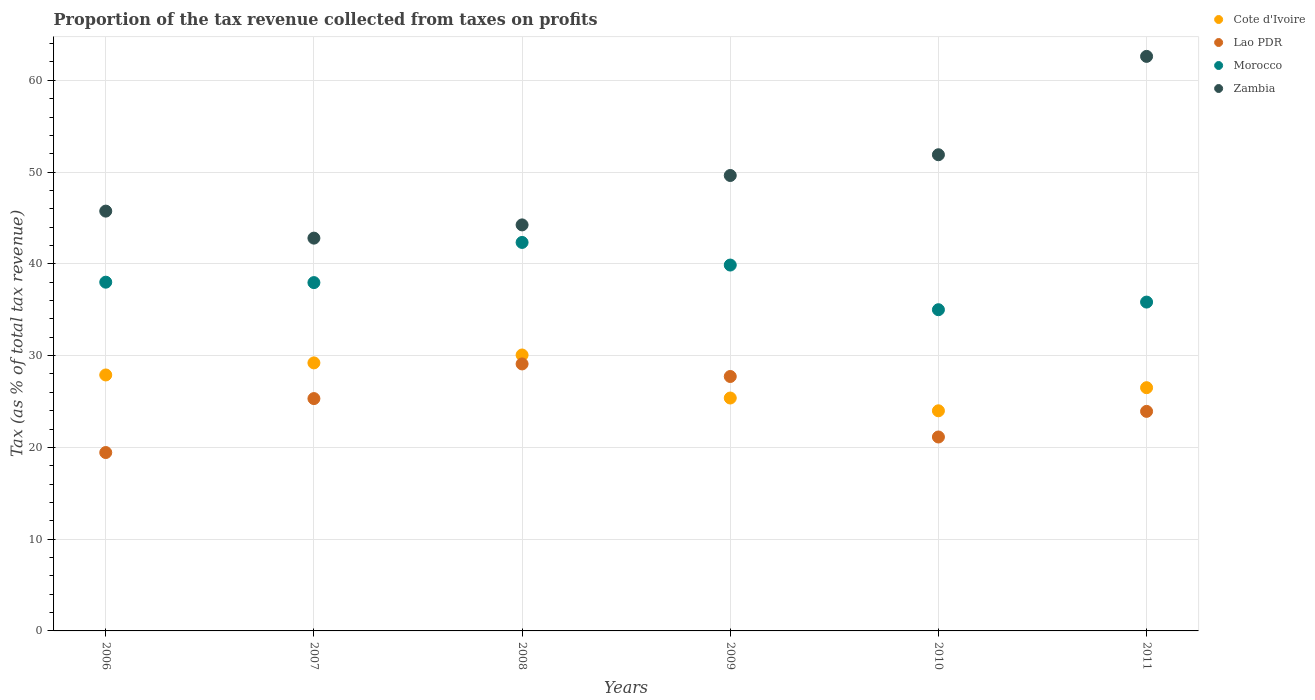Is the number of dotlines equal to the number of legend labels?
Your response must be concise. Yes. What is the proportion of the tax revenue collected in Lao PDR in 2006?
Offer a very short reply. 19.44. Across all years, what is the maximum proportion of the tax revenue collected in Cote d'Ivoire?
Give a very brief answer. 30.07. Across all years, what is the minimum proportion of the tax revenue collected in Lao PDR?
Ensure brevity in your answer.  19.44. What is the total proportion of the tax revenue collected in Zambia in the graph?
Your answer should be compact. 296.91. What is the difference between the proportion of the tax revenue collected in Lao PDR in 2008 and that in 2011?
Offer a terse response. 5.17. What is the difference between the proportion of the tax revenue collected in Morocco in 2010 and the proportion of the tax revenue collected in Zambia in 2007?
Your response must be concise. -7.8. What is the average proportion of the tax revenue collected in Zambia per year?
Provide a short and direct response. 49.48. In the year 2011, what is the difference between the proportion of the tax revenue collected in Zambia and proportion of the tax revenue collected in Morocco?
Offer a very short reply. 26.77. In how many years, is the proportion of the tax revenue collected in Morocco greater than 44 %?
Keep it short and to the point. 0. What is the ratio of the proportion of the tax revenue collected in Cote d'Ivoire in 2006 to that in 2010?
Keep it short and to the point. 1.16. Is the proportion of the tax revenue collected in Zambia in 2008 less than that in 2011?
Keep it short and to the point. Yes. Is the difference between the proportion of the tax revenue collected in Zambia in 2007 and 2011 greater than the difference between the proportion of the tax revenue collected in Morocco in 2007 and 2011?
Ensure brevity in your answer.  No. What is the difference between the highest and the second highest proportion of the tax revenue collected in Cote d'Ivoire?
Provide a short and direct response. 0.86. What is the difference between the highest and the lowest proportion of the tax revenue collected in Cote d'Ivoire?
Keep it short and to the point. 6.08. In how many years, is the proportion of the tax revenue collected in Zambia greater than the average proportion of the tax revenue collected in Zambia taken over all years?
Provide a succinct answer. 3. Is the sum of the proportion of the tax revenue collected in Zambia in 2010 and 2011 greater than the maximum proportion of the tax revenue collected in Cote d'Ivoire across all years?
Your answer should be compact. Yes. Does the proportion of the tax revenue collected in Cote d'Ivoire monotonically increase over the years?
Ensure brevity in your answer.  No. Is the proportion of the tax revenue collected in Cote d'Ivoire strictly less than the proportion of the tax revenue collected in Morocco over the years?
Your answer should be very brief. Yes. What is the difference between two consecutive major ticks on the Y-axis?
Your answer should be very brief. 10. What is the title of the graph?
Offer a very short reply. Proportion of the tax revenue collected from taxes on profits. Does "Malta" appear as one of the legend labels in the graph?
Provide a short and direct response. No. What is the label or title of the X-axis?
Keep it short and to the point. Years. What is the label or title of the Y-axis?
Offer a very short reply. Tax (as % of total tax revenue). What is the Tax (as % of total tax revenue) in Cote d'Ivoire in 2006?
Your answer should be compact. 27.89. What is the Tax (as % of total tax revenue) of Lao PDR in 2006?
Ensure brevity in your answer.  19.44. What is the Tax (as % of total tax revenue) of Morocco in 2006?
Ensure brevity in your answer.  38. What is the Tax (as % of total tax revenue) in Zambia in 2006?
Offer a very short reply. 45.74. What is the Tax (as % of total tax revenue) of Cote d'Ivoire in 2007?
Offer a terse response. 29.21. What is the Tax (as % of total tax revenue) of Lao PDR in 2007?
Your answer should be compact. 25.32. What is the Tax (as % of total tax revenue) of Morocco in 2007?
Offer a terse response. 37.96. What is the Tax (as % of total tax revenue) in Zambia in 2007?
Keep it short and to the point. 42.8. What is the Tax (as % of total tax revenue) in Cote d'Ivoire in 2008?
Your answer should be very brief. 30.07. What is the Tax (as % of total tax revenue) in Lao PDR in 2008?
Keep it short and to the point. 29.09. What is the Tax (as % of total tax revenue) in Morocco in 2008?
Ensure brevity in your answer.  42.33. What is the Tax (as % of total tax revenue) in Zambia in 2008?
Ensure brevity in your answer.  44.24. What is the Tax (as % of total tax revenue) of Cote d'Ivoire in 2009?
Give a very brief answer. 25.38. What is the Tax (as % of total tax revenue) of Lao PDR in 2009?
Provide a succinct answer. 27.72. What is the Tax (as % of total tax revenue) of Morocco in 2009?
Make the answer very short. 39.87. What is the Tax (as % of total tax revenue) in Zambia in 2009?
Keep it short and to the point. 49.63. What is the Tax (as % of total tax revenue) of Cote d'Ivoire in 2010?
Your response must be concise. 23.99. What is the Tax (as % of total tax revenue) of Lao PDR in 2010?
Your answer should be compact. 21.13. What is the Tax (as % of total tax revenue) of Morocco in 2010?
Your response must be concise. 35. What is the Tax (as % of total tax revenue) in Zambia in 2010?
Offer a terse response. 51.89. What is the Tax (as % of total tax revenue) in Cote d'Ivoire in 2011?
Provide a short and direct response. 26.5. What is the Tax (as % of total tax revenue) of Lao PDR in 2011?
Offer a very short reply. 23.92. What is the Tax (as % of total tax revenue) of Morocco in 2011?
Offer a very short reply. 35.83. What is the Tax (as % of total tax revenue) of Zambia in 2011?
Offer a terse response. 62.61. Across all years, what is the maximum Tax (as % of total tax revenue) of Cote d'Ivoire?
Your response must be concise. 30.07. Across all years, what is the maximum Tax (as % of total tax revenue) of Lao PDR?
Keep it short and to the point. 29.09. Across all years, what is the maximum Tax (as % of total tax revenue) in Morocco?
Offer a very short reply. 42.33. Across all years, what is the maximum Tax (as % of total tax revenue) of Zambia?
Provide a succinct answer. 62.61. Across all years, what is the minimum Tax (as % of total tax revenue) in Cote d'Ivoire?
Your answer should be compact. 23.99. Across all years, what is the minimum Tax (as % of total tax revenue) in Lao PDR?
Your answer should be compact. 19.44. Across all years, what is the minimum Tax (as % of total tax revenue) in Morocco?
Your response must be concise. 35. Across all years, what is the minimum Tax (as % of total tax revenue) of Zambia?
Ensure brevity in your answer.  42.8. What is the total Tax (as % of total tax revenue) in Cote d'Ivoire in the graph?
Ensure brevity in your answer.  163.03. What is the total Tax (as % of total tax revenue) in Lao PDR in the graph?
Ensure brevity in your answer.  146.63. What is the total Tax (as % of total tax revenue) of Morocco in the graph?
Your answer should be compact. 228.99. What is the total Tax (as % of total tax revenue) in Zambia in the graph?
Provide a succinct answer. 296.91. What is the difference between the Tax (as % of total tax revenue) in Cote d'Ivoire in 2006 and that in 2007?
Offer a terse response. -1.31. What is the difference between the Tax (as % of total tax revenue) of Lao PDR in 2006 and that in 2007?
Make the answer very short. -5.88. What is the difference between the Tax (as % of total tax revenue) in Morocco in 2006 and that in 2007?
Offer a very short reply. 0.05. What is the difference between the Tax (as % of total tax revenue) of Zambia in 2006 and that in 2007?
Ensure brevity in your answer.  2.94. What is the difference between the Tax (as % of total tax revenue) in Cote d'Ivoire in 2006 and that in 2008?
Offer a very short reply. -2.18. What is the difference between the Tax (as % of total tax revenue) of Lao PDR in 2006 and that in 2008?
Provide a succinct answer. -9.66. What is the difference between the Tax (as % of total tax revenue) of Morocco in 2006 and that in 2008?
Your answer should be compact. -4.33. What is the difference between the Tax (as % of total tax revenue) of Zambia in 2006 and that in 2008?
Provide a succinct answer. 1.5. What is the difference between the Tax (as % of total tax revenue) of Cote d'Ivoire in 2006 and that in 2009?
Make the answer very short. 2.51. What is the difference between the Tax (as % of total tax revenue) in Lao PDR in 2006 and that in 2009?
Provide a short and direct response. -8.29. What is the difference between the Tax (as % of total tax revenue) in Morocco in 2006 and that in 2009?
Keep it short and to the point. -1.87. What is the difference between the Tax (as % of total tax revenue) in Zambia in 2006 and that in 2009?
Provide a short and direct response. -3.88. What is the difference between the Tax (as % of total tax revenue) of Cote d'Ivoire in 2006 and that in 2010?
Keep it short and to the point. 3.91. What is the difference between the Tax (as % of total tax revenue) of Lao PDR in 2006 and that in 2010?
Offer a very short reply. -1.69. What is the difference between the Tax (as % of total tax revenue) of Morocco in 2006 and that in 2010?
Give a very brief answer. 3. What is the difference between the Tax (as % of total tax revenue) of Zambia in 2006 and that in 2010?
Provide a succinct answer. -6.14. What is the difference between the Tax (as % of total tax revenue) of Cote d'Ivoire in 2006 and that in 2011?
Your response must be concise. 1.39. What is the difference between the Tax (as % of total tax revenue) of Lao PDR in 2006 and that in 2011?
Make the answer very short. -4.49. What is the difference between the Tax (as % of total tax revenue) in Morocco in 2006 and that in 2011?
Your response must be concise. 2.17. What is the difference between the Tax (as % of total tax revenue) of Zambia in 2006 and that in 2011?
Your answer should be very brief. -16.86. What is the difference between the Tax (as % of total tax revenue) in Cote d'Ivoire in 2007 and that in 2008?
Provide a succinct answer. -0.86. What is the difference between the Tax (as % of total tax revenue) of Lao PDR in 2007 and that in 2008?
Give a very brief answer. -3.78. What is the difference between the Tax (as % of total tax revenue) in Morocco in 2007 and that in 2008?
Your answer should be very brief. -4.38. What is the difference between the Tax (as % of total tax revenue) of Zambia in 2007 and that in 2008?
Provide a succinct answer. -1.44. What is the difference between the Tax (as % of total tax revenue) of Cote d'Ivoire in 2007 and that in 2009?
Give a very brief answer. 3.83. What is the difference between the Tax (as % of total tax revenue) of Lao PDR in 2007 and that in 2009?
Provide a succinct answer. -2.41. What is the difference between the Tax (as % of total tax revenue) of Morocco in 2007 and that in 2009?
Your answer should be very brief. -1.91. What is the difference between the Tax (as % of total tax revenue) of Zambia in 2007 and that in 2009?
Your answer should be very brief. -6.83. What is the difference between the Tax (as % of total tax revenue) of Cote d'Ivoire in 2007 and that in 2010?
Provide a short and direct response. 5.22. What is the difference between the Tax (as % of total tax revenue) of Lao PDR in 2007 and that in 2010?
Offer a very short reply. 4.19. What is the difference between the Tax (as % of total tax revenue) in Morocco in 2007 and that in 2010?
Your answer should be compact. 2.95. What is the difference between the Tax (as % of total tax revenue) in Zambia in 2007 and that in 2010?
Ensure brevity in your answer.  -9.09. What is the difference between the Tax (as % of total tax revenue) in Cote d'Ivoire in 2007 and that in 2011?
Offer a terse response. 2.7. What is the difference between the Tax (as % of total tax revenue) of Lao PDR in 2007 and that in 2011?
Offer a very short reply. 1.39. What is the difference between the Tax (as % of total tax revenue) in Morocco in 2007 and that in 2011?
Your answer should be compact. 2.12. What is the difference between the Tax (as % of total tax revenue) in Zambia in 2007 and that in 2011?
Offer a terse response. -19.8. What is the difference between the Tax (as % of total tax revenue) in Cote d'Ivoire in 2008 and that in 2009?
Your answer should be very brief. 4.69. What is the difference between the Tax (as % of total tax revenue) of Lao PDR in 2008 and that in 2009?
Offer a terse response. 1.37. What is the difference between the Tax (as % of total tax revenue) of Morocco in 2008 and that in 2009?
Offer a terse response. 2.46. What is the difference between the Tax (as % of total tax revenue) of Zambia in 2008 and that in 2009?
Ensure brevity in your answer.  -5.38. What is the difference between the Tax (as % of total tax revenue) in Cote d'Ivoire in 2008 and that in 2010?
Give a very brief answer. 6.08. What is the difference between the Tax (as % of total tax revenue) of Lao PDR in 2008 and that in 2010?
Provide a short and direct response. 7.96. What is the difference between the Tax (as % of total tax revenue) in Morocco in 2008 and that in 2010?
Offer a terse response. 7.33. What is the difference between the Tax (as % of total tax revenue) in Zambia in 2008 and that in 2010?
Your answer should be compact. -7.64. What is the difference between the Tax (as % of total tax revenue) of Cote d'Ivoire in 2008 and that in 2011?
Keep it short and to the point. 3.56. What is the difference between the Tax (as % of total tax revenue) of Lao PDR in 2008 and that in 2011?
Provide a succinct answer. 5.17. What is the difference between the Tax (as % of total tax revenue) in Morocco in 2008 and that in 2011?
Offer a very short reply. 6.5. What is the difference between the Tax (as % of total tax revenue) in Zambia in 2008 and that in 2011?
Keep it short and to the point. -18.36. What is the difference between the Tax (as % of total tax revenue) of Cote d'Ivoire in 2009 and that in 2010?
Give a very brief answer. 1.39. What is the difference between the Tax (as % of total tax revenue) in Lao PDR in 2009 and that in 2010?
Make the answer very short. 6.59. What is the difference between the Tax (as % of total tax revenue) in Morocco in 2009 and that in 2010?
Make the answer very short. 4.87. What is the difference between the Tax (as % of total tax revenue) of Zambia in 2009 and that in 2010?
Provide a short and direct response. -2.26. What is the difference between the Tax (as % of total tax revenue) of Cote d'Ivoire in 2009 and that in 2011?
Make the answer very short. -1.12. What is the difference between the Tax (as % of total tax revenue) of Lao PDR in 2009 and that in 2011?
Ensure brevity in your answer.  3.8. What is the difference between the Tax (as % of total tax revenue) in Morocco in 2009 and that in 2011?
Provide a succinct answer. 4.04. What is the difference between the Tax (as % of total tax revenue) in Zambia in 2009 and that in 2011?
Your response must be concise. -12.98. What is the difference between the Tax (as % of total tax revenue) in Cote d'Ivoire in 2010 and that in 2011?
Offer a terse response. -2.52. What is the difference between the Tax (as % of total tax revenue) in Lao PDR in 2010 and that in 2011?
Make the answer very short. -2.79. What is the difference between the Tax (as % of total tax revenue) of Morocco in 2010 and that in 2011?
Provide a succinct answer. -0.83. What is the difference between the Tax (as % of total tax revenue) of Zambia in 2010 and that in 2011?
Provide a succinct answer. -10.72. What is the difference between the Tax (as % of total tax revenue) in Cote d'Ivoire in 2006 and the Tax (as % of total tax revenue) in Lao PDR in 2007?
Ensure brevity in your answer.  2.57. What is the difference between the Tax (as % of total tax revenue) in Cote d'Ivoire in 2006 and the Tax (as % of total tax revenue) in Morocco in 2007?
Provide a succinct answer. -10.06. What is the difference between the Tax (as % of total tax revenue) in Cote d'Ivoire in 2006 and the Tax (as % of total tax revenue) in Zambia in 2007?
Your answer should be compact. -14.91. What is the difference between the Tax (as % of total tax revenue) in Lao PDR in 2006 and the Tax (as % of total tax revenue) in Morocco in 2007?
Offer a very short reply. -18.52. What is the difference between the Tax (as % of total tax revenue) in Lao PDR in 2006 and the Tax (as % of total tax revenue) in Zambia in 2007?
Ensure brevity in your answer.  -23.36. What is the difference between the Tax (as % of total tax revenue) in Morocco in 2006 and the Tax (as % of total tax revenue) in Zambia in 2007?
Provide a succinct answer. -4.8. What is the difference between the Tax (as % of total tax revenue) of Cote d'Ivoire in 2006 and the Tax (as % of total tax revenue) of Lao PDR in 2008?
Make the answer very short. -1.2. What is the difference between the Tax (as % of total tax revenue) in Cote d'Ivoire in 2006 and the Tax (as % of total tax revenue) in Morocco in 2008?
Give a very brief answer. -14.44. What is the difference between the Tax (as % of total tax revenue) of Cote d'Ivoire in 2006 and the Tax (as % of total tax revenue) of Zambia in 2008?
Your answer should be very brief. -16.35. What is the difference between the Tax (as % of total tax revenue) in Lao PDR in 2006 and the Tax (as % of total tax revenue) in Morocco in 2008?
Your answer should be compact. -22.89. What is the difference between the Tax (as % of total tax revenue) in Lao PDR in 2006 and the Tax (as % of total tax revenue) in Zambia in 2008?
Make the answer very short. -24.81. What is the difference between the Tax (as % of total tax revenue) of Morocco in 2006 and the Tax (as % of total tax revenue) of Zambia in 2008?
Offer a terse response. -6.24. What is the difference between the Tax (as % of total tax revenue) of Cote d'Ivoire in 2006 and the Tax (as % of total tax revenue) of Lao PDR in 2009?
Provide a succinct answer. 0.17. What is the difference between the Tax (as % of total tax revenue) in Cote d'Ivoire in 2006 and the Tax (as % of total tax revenue) in Morocco in 2009?
Give a very brief answer. -11.98. What is the difference between the Tax (as % of total tax revenue) in Cote d'Ivoire in 2006 and the Tax (as % of total tax revenue) in Zambia in 2009?
Make the answer very short. -21.74. What is the difference between the Tax (as % of total tax revenue) in Lao PDR in 2006 and the Tax (as % of total tax revenue) in Morocco in 2009?
Offer a terse response. -20.43. What is the difference between the Tax (as % of total tax revenue) in Lao PDR in 2006 and the Tax (as % of total tax revenue) in Zambia in 2009?
Give a very brief answer. -30.19. What is the difference between the Tax (as % of total tax revenue) in Morocco in 2006 and the Tax (as % of total tax revenue) in Zambia in 2009?
Your response must be concise. -11.63. What is the difference between the Tax (as % of total tax revenue) of Cote d'Ivoire in 2006 and the Tax (as % of total tax revenue) of Lao PDR in 2010?
Ensure brevity in your answer.  6.76. What is the difference between the Tax (as % of total tax revenue) of Cote d'Ivoire in 2006 and the Tax (as % of total tax revenue) of Morocco in 2010?
Your answer should be compact. -7.11. What is the difference between the Tax (as % of total tax revenue) in Cote d'Ivoire in 2006 and the Tax (as % of total tax revenue) in Zambia in 2010?
Keep it short and to the point. -24. What is the difference between the Tax (as % of total tax revenue) of Lao PDR in 2006 and the Tax (as % of total tax revenue) of Morocco in 2010?
Keep it short and to the point. -15.56. What is the difference between the Tax (as % of total tax revenue) in Lao PDR in 2006 and the Tax (as % of total tax revenue) in Zambia in 2010?
Offer a terse response. -32.45. What is the difference between the Tax (as % of total tax revenue) in Morocco in 2006 and the Tax (as % of total tax revenue) in Zambia in 2010?
Provide a succinct answer. -13.89. What is the difference between the Tax (as % of total tax revenue) in Cote d'Ivoire in 2006 and the Tax (as % of total tax revenue) in Lao PDR in 2011?
Provide a short and direct response. 3.97. What is the difference between the Tax (as % of total tax revenue) in Cote d'Ivoire in 2006 and the Tax (as % of total tax revenue) in Morocco in 2011?
Your answer should be compact. -7.94. What is the difference between the Tax (as % of total tax revenue) of Cote d'Ivoire in 2006 and the Tax (as % of total tax revenue) of Zambia in 2011?
Provide a succinct answer. -34.71. What is the difference between the Tax (as % of total tax revenue) of Lao PDR in 2006 and the Tax (as % of total tax revenue) of Morocco in 2011?
Provide a short and direct response. -16.4. What is the difference between the Tax (as % of total tax revenue) of Lao PDR in 2006 and the Tax (as % of total tax revenue) of Zambia in 2011?
Provide a short and direct response. -43.17. What is the difference between the Tax (as % of total tax revenue) of Morocco in 2006 and the Tax (as % of total tax revenue) of Zambia in 2011?
Provide a succinct answer. -24.6. What is the difference between the Tax (as % of total tax revenue) in Cote d'Ivoire in 2007 and the Tax (as % of total tax revenue) in Lao PDR in 2008?
Provide a succinct answer. 0.11. What is the difference between the Tax (as % of total tax revenue) of Cote d'Ivoire in 2007 and the Tax (as % of total tax revenue) of Morocco in 2008?
Provide a short and direct response. -13.13. What is the difference between the Tax (as % of total tax revenue) in Cote d'Ivoire in 2007 and the Tax (as % of total tax revenue) in Zambia in 2008?
Keep it short and to the point. -15.04. What is the difference between the Tax (as % of total tax revenue) of Lao PDR in 2007 and the Tax (as % of total tax revenue) of Morocco in 2008?
Your answer should be compact. -17.01. What is the difference between the Tax (as % of total tax revenue) in Lao PDR in 2007 and the Tax (as % of total tax revenue) in Zambia in 2008?
Your answer should be very brief. -18.93. What is the difference between the Tax (as % of total tax revenue) of Morocco in 2007 and the Tax (as % of total tax revenue) of Zambia in 2008?
Your answer should be very brief. -6.29. What is the difference between the Tax (as % of total tax revenue) of Cote d'Ivoire in 2007 and the Tax (as % of total tax revenue) of Lao PDR in 2009?
Your response must be concise. 1.48. What is the difference between the Tax (as % of total tax revenue) of Cote d'Ivoire in 2007 and the Tax (as % of total tax revenue) of Morocco in 2009?
Offer a terse response. -10.66. What is the difference between the Tax (as % of total tax revenue) of Cote d'Ivoire in 2007 and the Tax (as % of total tax revenue) of Zambia in 2009?
Offer a terse response. -20.42. What is the difference between the Tax (as % of total tax revenue) in Lao PDR in 2007 and the Tax (as % of total tax revenue) in Morocco in 2009?
Offer a terse response. -14.55. What is the difference between the Tax (as % of total tax revenue) in Lao PDR in 2007 and the Tax (as % of total tax revenue) in Zambia in 2009?
Offer a very short reply. -24.31. What is the difference between the Tax (as % of total tax revenue) of Morocco in 2007 and the Tax (as % of total tax revenue) of Zambia in 2009?
Give a very brief answer. -11.67. What is the difference between the Tax (as % of total tax revenue) in Cote d'Ivoire in 2007 and the Tax (as % of total tax revenue) in Lao PDR in 2010?
Keep it short and to the point. 8.07. What is the difference between the Tax (as % of total tax revenue) in Cote d'Ivoire in 2007 and the Tax (as % of total tax revenue) in Morocco in 2010?
Offer a terse response. -5.8. What is the difference between the Tax (as % of total tax revenue) in Cote d'Ivoire in 2007 and the Tax (as % of total tax revenue) in Zambia in 2010?
Your answer should be very brief. -22.68. What is the difference between the Tax (as % of total tax revenue) in Lao PDR in 2007 and the Tax (as % of total tax revenue) in Morocco in 2010?
Your answer should be compact. -9.68. What is the difference between the Tax (as % of total tax revenue) in Lao PDR in 2007 and the Tax (as % of total tax revenue) in Zambia in 2010?
Offer a terse response. -26.57. What is the difference between the Tax (as % of total tax revenue) of Morocco in 2007 and the Tax (as % of total tax revenue) of Zambia in 2010?
Ensure brevity in your answer.  -13.93. What is the difference between the Tax (as % of total tax revenue) of Cote d'Ivoire in 2007 and the Tax (as % of total tax revenue) of Lao PDR in 2011?
Ensure brevity in your answer.  5.28. What is the difference between the Tax (as % of total tax revenue) in Cote d'Ivoire in 2007 and the Tax (as % of total tax revenue) in Morocco in 2011?
Provide a short and direct response. -6.63. What is the difference between the Tax (as % of total tax revenue) of Cote d'Ivoire in 2007 and the Tax (as % of total tax revenue) of Zambia in 2011?
Give a very brief answer. -33.4. What is the difference between the Tax (as % of total tax revenue) in Lao PDR in 2007 and the Tax (as % of total tax revenue) in Morocco in 2011?
Offer a very short reply. -10.52. What is the difference between the Tax (as % of total tax revenue) of Lao PDR in 2007 and the Tax (as % of total tax revenue) of Zambia in 2011?
Give a very brief answer. -37.29. What is the difference between the Tax (as % of total tax revenue) in Morocco in 2007 and the Tax (as % of total tax revenue) in Zambia in 2011?
Your response must be concise. -24.65. What is the difference between the Tax (as % of total tax revenue) of Cote d'Ivoire in 2008 and the Tax (as % of total tax revenue) of Lao PDR in 2009?
Keep it short and to the point. 2.34. What is the difference between the Tax (as % of total tax revenue) in Cote d'Ivoire in 2008 and the Tax (as % of total tax revenue) in Morocco in 2009?
Give a very brief answer. -9.8. What is the difference between the Tax (as % of total tax revenue) in Cote d'Ivoire in 2008 and the Tax (as % of total tax revenue) in Zambia in 2009?
Offer a very short reply. -19.56. What is the difference between the Tax (as % of total tax revenue) of Lao PDR in 2008 and the Tax (as % of total tax revenue) of Morocco in 2009?
Your answer should be compact. -10.77. What is the difference between the Tax (as % of total tax revenue) in Lao PDR in 2008 and the Tax (as % of total tax revenue) in Zambia in 2009?
Your answer should be compact. -20.53. What is the difference between the Tax (as % of total tax revenue) in Morocco in 2008 and the Tax (as % of total tax revenue) in Zambia in 2009?
Ensure brevity in your answer.  -7.29. What is the difference between the Tax (as % of total tax revenue) of Cote d'Ivoire in 2008 and the Tax (as % of total tax revenue) of Lao PDR in 2010?
Provide a succinct answer. 8.93. What is the difference between the Tax (as % of total tax revenue) in Cote d'Ivoire in 2008 and the Tax (as % of total tax revenue) in Morocco in 2010?
Your response must be concise. -4.93. What is the difference between the Tax (as % of total tax revenue) in Cote d'Ivoire in 2008 and the Tax (as % of total tax revenue) in Zambia in 2010?
Provide a short and direct response. -21.82. What is the difference between the Tax (as % of total tax revenue) in Lao PDR in 2008 and the Tax (as % of total tax revenue) in Morocco in 2010?
Offer a terse response. -5.91. What is the difference between the Tax (as % of total tax revenue) of Lao PDR in 2008 and the Tax (as % of total tax revenue) of Zambia in 2010?
Ensure brevity in your answer.  -22.79. What is the difference between the Tax (as % of total tax revenue) in Morocco in 2008 and the Tax (as % of total tax revenue) in Zambia in 2010?
Offer a terse response. -9.56. What is the difference between the Tax (as % of total tax revenue) of Cote d'Ivoire in 2008 and the Tax (as % of total tax revenue) of Lao PDR in 2011?
Give a very brief answer. 6.14. What is the difference between the Tax (as % of total tax revenue) of Cote d'Ivoire in 2008 and the Tax (as % of total tax revenue) of Morocco in 2011?
Your answer should be compact. -5.77. What is the difference between the Tax (as % of total tax revenue) in Cote d'Ivoire in 2008 and the Tax (as % of total tax revenue) in Zambia in 2011?
Give a very brief answer. -32.54. What is the difference between the Tax (as % of total tax revenue) of Lao PDR in 2008 and the Tax (as % of total tax revenue) of Morocco in 2011?
Provide a succinct answer. -6.74. What is the difference between the Tax (as % of total tax revenue) of Lao PDR in 2008 and the Tax (as % of total tax revenue) of Zambia in 2011?
Your response must be concise. -33.51. What is the difference between the Tax (as % of total tax revenue) of Morocco in 2008 and the Tax (as % of total tax revenue) of Zambia in 2011?
Offer a terse response. -20.27. What is the difference between the Tax (as % of total tax revenue) of Cote d'Ivoire in 2009 and the Tax (as % of total tax revenue) of Lao PDR in 2010?
Keep it short and to the point. 4.25. What is the difference between the Tax (as % of total tax revenue) in Cote d'Ivoire in 2009 and the Tax (as % of total tax revenue) in Morocco in 2010?
Offer a very short reply. -9.62. What is the difference between the Tax (as % of total tax revenue) of Cote d'Ivoire in 2009 and the Tax (as % of total tax revenue) of Zambia in 2010?
Give a very brief answer. -26.51. What is the difference between the Tax (as % of total tax revenue) in Lao PDR in 2009 and the Tax (as % of total tax revenue) in Morocco in 2010?
Your answer should be compact. -7.28. What is the difference between the Tax (as % of total tax revenue) in Lao PDR in 2009 and the Tax (as % of total tax revenue) in Zambia in 2010?
Your answer should be very brief. -24.16. What is the difference between the Tax (as % of total tax revenue) of Morocco in 2009 and the Tax (as % of total tax revenue) of Zambia in 2010?
Your response must be concise. -12.02. What is the difference between the Tax (as % of total tax revenue) of Cote d'Ivoire in 2009 and the Tax (as % of total tax revenue) of Lao PDR in 2011?
Provide a succinct answer. 1.46. What is the difference between the Tax (as % of total tax revenue) of Cote d'Ivoire in 2009 and the Tax (as % of total tax revenue) of Morocco in 2011?
Keep it short and to the point. -10.45. What is the difference between the Tax (as % of total tax revenue) of Cote d'Ivoire in 2009 and the Tax (as % of total tax revenue) of Zambia in 2011?
Your answer should be very brief. -37.23. What is the difference between the Tax (as % of total tax revenue) of Lao PDR in 2009 and the Tax (as % of total tax revenue) of Morocco in 2011?
Give a very brief answer. -8.11. What is the difference between the Tax (as % of total tax revenue) of Lao PDR in 2009 and the Tax (as % of total tax revenue) of Zambia in 2011?
Offer a terse response. -34.88. What is the difference between the Tax (as % of total tax revenue) in Morocco in 2009 and the Tax (as % of total tax revenue) in Zambia in 2011?
Make the answer very short. -22.74. What is the difference between the Tax (as % of total tax revenue) in Cote d'Ivoire in 2010 and the Tax (as % of total tax revenue) in Lao PDR in 2011?
Keep it short and to the point. 0.06. What is the difference between the Tax (as % of total tax revenue) of Cote d'Ivoire in 2010 and the Tax (as % of total tax revenue) of Morocco in 2011?
Provide a succinct answer. -11.85. What is the difference between the Tax (as % of total tax revenue) in Cote d'Ivoire in 2010 and the Tax (as % of total tax revenue) in Zambia in 2011?
Give a very brief answer. -38.62. What is the difference between the Tax (as % of total tax revenue) in Lao PDR in 2010 and the Tax (as % of total tax revenue) in Morocco in 2011?
Ensure brevity in your answer.  -14.7. What is the difference between the Tax (as % of total tax revenue) of Lao PDR in 2010 and the Tax (as % of total tax revenue) of Zambia in 2011?
Provide a succinct answer. -41.47. What is the difference between the Tax (as % of total tax revenue) in Morocco in 2010 and the Tax (as % of total tax revenue) in Zambia in 2011?
Give a very brief answer. -27.6. What is the average Tax (as % of total tax revenue) in Cote d'Ivoire per year?
Give a very brief answer. 27.17. What is the average Tax (as % of total tax revenue) in Lao PDR per year?
Offer a terse response. 24.44. What is the average Tax (as % of total tax revenue) of Morocco per year?
Your response must be concise. 38.17. What is the average Tax (as % of total tax revenue) of Zambia per year?
Give a very brief answer. 49.48. In the year 2006, what is the difference between the Tax (as % of total tax revenue) in Cote d'Ivoire and Tax (as % of total tax revenue) in Lao PDR?
Your answer should be compact. 8.45. In the year 2006, what is the difference between the Tax (as % of total tax revenue) in Cote d'Ivoire and Tax (as % of total tax revenue) in Morocco?
Give a very brief answer. -10.11. In the year 2006, what is the difference between the Tax (as % of total tax revenue) in Cote d'Ivoire and Tax (as % of total tax revenue) in Zambia?
Ensure brevity in your answer.  -17.85. In the year 2006, what is the difference between the Tax (as % of total tax revenue) in Lao PDR and Tax (as % of total tax revenue) in Morocco?
Provide a short and direct response. -18.56. In the year 2006, what is the difference between the Tax (as % of total tax revenue) of Lao PDR and Tax (as % of total tax revenue) of Zambia?
Offer a terse response. -26.31. In the year 2006, what is the difference between the Tax (as % of total tax revenue) in Morocco and Tax (as % of total tax revenue) in Zambia?
Make the answer very short. -7.74. In the year 2007, what is the difference between the Tax (as % of total tax revenue) in Cote d'Ivoire and Tax (as % of total tax revenue) in Lao PDR?
Offer a very short reply. 3.89. In the year 2007, what is the difference between the Tax (as % of total tax revenue) of Cote d'Ivoire and Tax (as % of total tax revenue) of Morocco?
Keep it short and to the point. -8.75. In the year 2007, what is the difference between the Tax (as % of total tax revenue) in Cote d'Ivoire and Tax (as % of total tax revenue) in Zambia?
Give a very brief answer. -13.6. In the year 2007, what is the difference between the Tax (as % of total tax revenue) in Lao PDR and Tax (as % of total tax revenue) in Morocco?
Provide a short and direct response. -12.64. In the year 2007, what is the difference between the Tax (as % of total tax revenue) in Lao PDR and Tax (as % of total tax revenue) in Zambia?
Your response must be concise. -17.48. In the year 2007, what is the difference between the Tax (as % of total tax revenue) of Morocco and Tax (as % of total tax revenue) of Zambia?
Keep it short and to the point. -4.85. In the year 2008, what is the difference between the Tax (as % of total tax revenue) in Cote d'Ivoire and Tax (as % of total tax revenue) in Lao PDR?
Give a very brief answer. 0.97. In the year 2008, what is the difference between the Tax (as % of total tax revenue) of Cote d'Ivoire and Tax (as % of total tax revenue) of Morocco?
Your answer should be very brief. -12.26. In the year 2008, what is the difference between the Tax (as % of total tax revenue) in Cote d'Ivoire and Tax (as % of total tax revenue) in Zambia?
Your response must be concise. -14.18. In the year 2008, what is the difference between the Tax (as % of total tax revenue) of Lao PDR and Tax (as % of total tax revenue) of Morocco?
Offer a terse response. -13.24. In the year 2008, what is the difference between the Tax (as % of total tax revenue) in Lao PDR and Tax (as % of total tax revenue) in Zambia?
Your answer should be very brief. -15.15. In the year 2008, what is the difference between the Tax (as % of total tax revenue) in Morocco and Tax (as % of total tax revenue) in Zambia?
Ensure brevity in your answer.  -1.91. In the year 2009, what is the difference between the Tax (as % of total tax revenue) of Cote d'Ivoire and Tax (as % of total tax revenue) of Lao PDR?
Offer a very short reply. -2.35. In the year 2009, what is the difference between the Tax (as % of total tax revenue) in Cote d'Ivoire and Tax (as % of total tax revenue) in Morocco?
Give a very brief answer. -14.49. In the year 2009, what is the difference between the Tax (as % of total tax revenue) of Cote d'Ivoire and Tax (as % of total tax revenue) of Zambia?
Offer a terse response. -24.25. In the year 2009, what is the difference between the Tax (as % of total tax revenue) in Lao PDR and Tax (as % of total tax revenue) in Morocco?
Keep it short and to the point. -12.14. In the year 2009, what is the difference between the Tax (as % of total tax revenue) of Lao PDR and Tax (as % of total tax revenue) of Zambia?
Provide a succinct answer. -21.9. In the year 2009, what is the difference between the Tax (as % of total tax revenue) of Morocco and Tax (as % of total tax revenue) of Zambia?
Make the answer very short. -9.76. In the year 2010, what is the difference between the Tax (as % of total tax revenue) of Cote d'Ivoire and Tax (as % of total tax revenue) of Lao PDR?
Ensure brevity in your answer.  2.85. In the year 2010, what is the difference between the Tax (as % of total tax revenue) in Cote d'Ivoire and Tax (as % of total tax revenue) in Morocco?
Provide a short and direct response. -11.01. In the year 2010, what is the difference between the Tax (as % of total tax revenue) of Cote d'Ivoire and Tax (as % of total tax revenue) of Zambia?
Provide a short and direct response. -27.9. In the year 2010, what is the difference between the Tax (as % of total tax revenue) of Lao PDR and Tax (as % of total tax revenue) of Morocco?
Provide a succinct answer. -13.87. In the year 2010, what is the difference between the Tax (as % of total tax revenue) in Lao PDR and Tax (as % of total tax revenue) in Zambia?
Give a very brief answer. -30.76. In the year 2010, what is the difference between the Tax (as % of total tax revenue) of Morocco and Tax (as % of total tax revenue) of Zambia?
Give a very brief answer. -16.89. In the year 2011, what is the difference between the Tax (as % of total tax revenue) of Cote d'Ivoire and Tax (as % of total tax revenue) of Lao PDR?
Make the answer very short. 2.58. In the year 2011, what is the difference between the Tax (as % of total tax revenue) of Cote d'Ivoire and Tax (as % of total tax revenue) of Morocco?
Provide a short and direct response. -9.33. In the year 2011, what is the difference between the Tax (as % of total tax revenue) of Cote d'Ivoire and Tax (as % of total tax revenue) of Zambia?
Ensure brevity in your answer.  -36.1. In the year 2011, what is the difference between the Tax (as % of total tax revenue) in Lao PDR and Tax (as % of total tax revenue) in Morocco?
Your response must be concise. -11.91. In the year 2011, what is the difference between the Tax (as % of total tax revenue) in Lao PDR and Tax (as % of total tax revenue) in Zambia?
Offer a very short reply. -38.68. In the year 2011, what is the difference between the Tax (as % of total tax revenue) of Morocco and Tax (as % of total tax revenue) of Zambia?
Provide a short and direct response. -26.77. What is the ratio of the Tax (as % of total tax revenue) in Cote d'Ivoire in 2006 to that in 2007?
Your answer should be very brief. 0.95. What is the ratio of the Tax (as % of total tax revenue) of Lao PDR in 2006 to that in 2007?
Keep it short and to the point. 0.77. What is the ratio of the Tax (as % of total tax revenue) of Zambia in 2006 to that in 2007?
Offer a terse response. 1.07. What is the ratio of the Tax (as % of total tax revenue) of Cote d'Ivoire in 2006 to that in 2008?
Make the answer very short. 0.93. What is the ratio of the Tax (as % of total tax revenue) of Lao PDR in 2006 to that in 2008?
Your answer should be very brief. 0.67. What is the ratio of the Tax (as % of total tax revenue) of Morocco in 2006 to that in 2008?
Your answer should be compact. 0.9. What is the ratio of the Tax (as % of total tax revenue) of Zambia in 2006 to that in 2008?
Your answer should be very brief. 1.03. What is the ratio of the Tax (as % of total tax revenue) of Cote d'Ivoire in 2006 to that in 2009?
Keep it short and to the point. 1.1. What is the ratio of the Tax (as % of total tax revenue) in Lao PDR in 2006 to that in 2009?
Your answer should be very brief. 0.7. What is the ratio of the Tax (as % of total tax revenue) of Morocco in 2006 to that in 2009?
Offer a terse response. 0.95. What is the ratio of the Tax (as % of total tax revenue) in Zambia in 2006 to that in 2009?
Your response must be concise. 0.92. What is the ratio of the Tax (as % of total tax revenue) in Cote d'Ivoire in 2006 to that in 2010?
Offer a very short reply. 1.16. What is the ratio of the Tax (as % of total tax revenue) in Lao PDR in 2006 to that in 2010?
Provide a short and direct response. 0.92. What is the ratio of the Tax (as % of total tax revenue) in Morocco in 2006 to that in 2010?
Keep it short and to the point. 1.09. What is the ratio of the Tax (as % of total tax revenue) in Zambia in 2006 to that in 2010?
Your answer should be compact. 0.88. What is the ratio of the Tax (as % of total tax revenue) in Cote d'Ivoire in 2006 to that in 2011?
Keep it short and to the point. 1.05. What is the ratio of the Tax (as % of total tax revenue) of Lao PDR in 2006 to that in 2011?
Provide a short and direct response. 0.81. What is the ratio of the Tax (as % of total tax revenue) of Morocco in 2006 to that in 2011?
Ensure brevity in your answer.  1.06. What is the ratio of the Tax (as % of total tax revenue) of Zambia in 2006 to that in 2011?
Offer a terse response. 0.73. What is the ratio of the Tax (as % of total tax revenue) in Cote d'Ivoire in 2007 to that in 2008?
Make the answer very short. 0.97. What is the ratio of the Tax (as % of total tax revenue) of Lao PDR in 2007 to that in 2008?
Offer a terse response. 0.87. What is the ratio of the Tax (as % of total tax revenue) in Morocco in 2007 to that in 2008?
Give a very brief answer. 0.9. What is the ratio of the Tax (as % of total tax revenue) of Zambia in 2007 to that in 2008?
Your answer should be very brief. 0.97. What is the ratio of the Tax (as % of total tax revenue) in Cote d'Ivoire in 2007 to that in 2009?
Ensure brevity in your answer.  1.15. What is the ratio of the Tax (as % of total tax revenue) in Lao PDR in 2007 to that in 2009?
Give a very brief answer. 0.91. What is the ratio of the Tax (as % of total tax revenue) of Zambia in 2007 to that in 2009?
Your response must be concise. 0.86. What is the ratio of the Tax (as % of total tax revenue) of Cote d'Ivoire in 2007 to that in 2010?
Provide a succinct answer. 1.22. What is the ratio of the Tax (as % of total tax revenue) in Lao PDR in 2007 to that in 2010?
Give a very brief answer. 1.2. What is the ratio of the Tax (as % of total tax revenue) of Morocco in 2007 to that in 2010?
Provide a succinct answer. 1.08. What is the ratio of the Tax (as % of total tax revenue) in Zambia in 2007 to that in 2010?
Ensure brevity in your answer.  0.82. What is the ratio of the Tax (as % of total tax revenue) in Cote d'Ivoire in 2007 to that in 2011?
Provide a short and direct response. 1.1. What is the ratio of the Tax (as % of total tax revenue) in Lao PDR in 2007 to that in 2011?
Give a very brief answer. 1.06. What is the ratio of the Tax (as % of total tax revenue) in Morocco in 2007 to that in 2011?
Provide a short and direct response. 1.06. What is the ratio of the Tax (as % of total tax revenue) in Zambia in 2007 to that in 2011?
Keep it short and to the point. 0.68. What is the ratio of the Tax (as % of total tax revenue) of Cote d'Ivoire in 2008 to that in 2009?
Your answer should be compact. 1.18. What is the ratio of the Tax (as % of total tax revenue) in Lao PDR in 2008 to that in 2009?
Give a very brief answer. 1.05. What is the ratio of the Tax (as % of total tax revenue) in Morocco in 2008 to that in 2009?
Give a very brief answer. 1.06. What is the ratio of the Tax (as % of total tax revenue) of Zambia in 2008 to that in 2009?
Ensure brevity in your answer.  0.89. What is the ratio of the Tax (as % of total tax revenue) of Cote d'Ivoire in 2008 to that in 2010?
Offer a very short reply. 1.25. What is the ratio of the Tax (as % of total tax revenue) of Lao PDR in 2008 to that in 2010?
Make the answer very short. 1.38. What is the ratio of the Tax (as % of total tax revenue) of Morocco in 2008 to that in 2010?
Your answer should be very brief. 1.21. What is the ratio of the Tax (as % of total tax revenue) in Zambia in 2008 to that in 2010?
Ensure brevity in your answer.  0.85. What is the ratio of the Tax (as % of total tax revenue) in Cote d'Ivoire in 2008 to that in 2011?
Your answer should be compact. 1.13. What is the ratio of the Tax (as % of total tax revenue) of Lao PDR in 2008 to that in 2011?
Offer a very short reply. 1.22. What is the ratio of the Tax (as % of total tax revenue) of Morocco in 2008 to that in 2011?
Your answer should be very brief. 1.18. What is the ratio of the Tax (as % of total tax revenue) of Zambia in 2008 to that in 2011?
Your answer should be very brief. 0.71. What is the ratio of the Tax (as % of total tax revenue) of Cote d'Ivoire in 2009 to that in 2010?
Your answer should be very brief. 1.06. What is the ratio of the Tax (as % of total tax revenue) of Lao PDR in 2009 to that in 2010?
Offer a very short reply. 1.31. What is the ratio of the Tax (as % of total tax revenue) of Morocco in 2009 to that in 2010?
Your answer should be very brief. 1.14. What is the ratio of the Tax (as % of total tax revenue) in Zambia in 2009 to that in 2010?
Provide a succinct answer. 0.96. What is the ratio of the Tax (as % of total tax revenue) in Cote d'Ivoire in 2009 to that in 2011?
Provide a short and direct response. 0.96. What is the ratio of the Tax (as % of total tax revenue) of Lao PDR in 2009 to that in 2011?
Your response must be concise. 1.16. What is the ratio of the Tax (as % of total tax revenue) of Morocco in 2009 to that in 2011?
Offer a very short reply. 1.11. What is the ratio of the Tax (as % of total tax revenue) in Zambia in 2009 to that in 2011?
Your answer should be compact. 0.79. What is the ratio of the Tax (as % of total tax revenue) of Cote d'Ivoire in 2010 to that in 2011?
Ensure brevity in your answer.  0.91. What is the ratio of the Tax (as % of total tax revenue) in Lao PDR in 2010 to that in 2011?
Ensure brevity in your answer.  0.88. What is the ratio of the Tax (as % of total tax revenue) of Morocco in 2010 to that in 2011?
Provide a succinct answer. 0.98. What is the ratio of the Tax (as % of total tax revenue) in Zambia in 2010 to that in 2011?
Make the answer very short. 0.83. What is the difference between the highest and the second highest Tax (as % of total tax revenue) in Cote d'Ivoire?
Your answer should be compact. 0.86. What is the difference between the highest and the second highest Tax (as % of total tax revenue) in Lao PDR?
Your answer should be compact. 1.37. What is the difference between the highest and the second highest Tax (as % of total tax revenue) of Morocco?
Your response must be concise. 2.46. What is the difference between the highest and the second highest Tax (as % of total tax revenue) of Zambia?
Provide a succinct answer. 10.72. What is the difference between the highest and the lowest Tax (as % of total tax revenue) in Cote d'Ivoire?
Your answer should be compact. 6.08. What is the difference between the highest and the lowest Tax (as % of total tax revenue) in Lao PDR?
Offer a very short reply. 9.66. What is the difference between the highest and the lowest Tax (as % of total tax revenue) of Morocco?
Provide a short and direct response. 7.33. What is the difference between the highest and the lowest Tax (as % of total tax revenue) in Zambia?
Offer a very short reply. 19.8. 